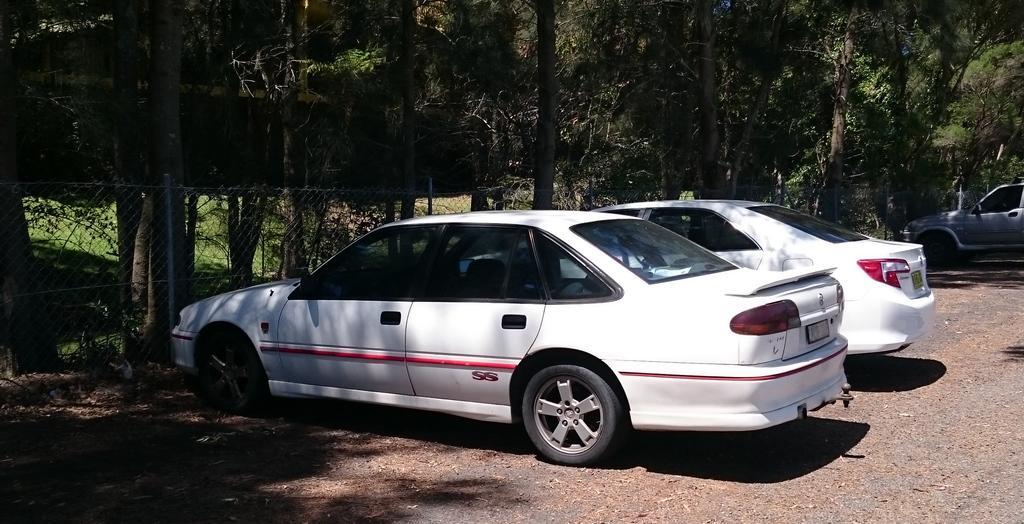Could you give a brief overview of what you see in this image? In this image, we can see cars on the road and in the background, there are trees and we can see a mesh. 